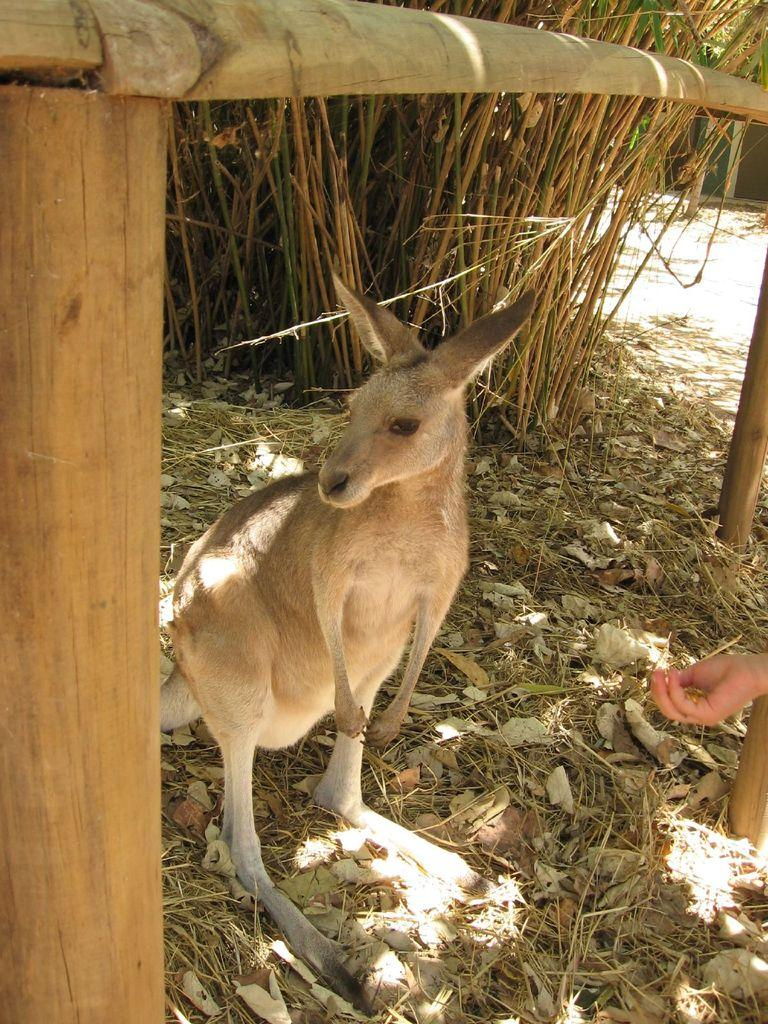What type of animal is in the image? The type of animal cannot be determined from the provided facts. What part of a person can be seen in the image? There is a hand of a person in the image. What type of vegetation is present in the image? There are leaves and grass in the image. What type of structure is in the image? There are wooden poles in the image. What type of friction is present between the animal and the wooden poles in the image? There is no animal present in the image, so there is no friction between an animal and the wooden poles. What offer is being made by the person in the image? There is no indication of an offer being made in the image, as only a hand of a person is visible. 